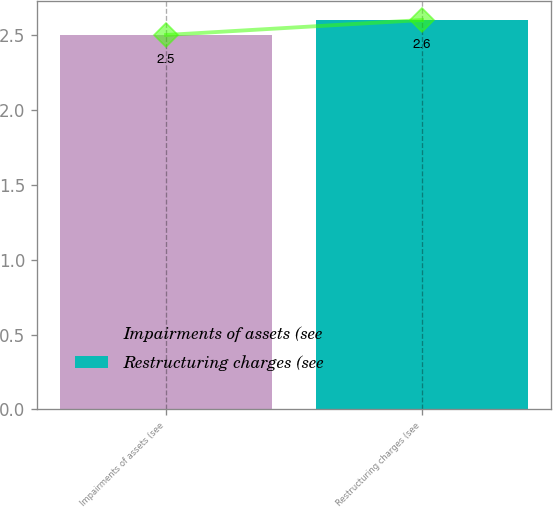Convert chart to OTSL. <chart><loc_0><loc_0><loc_500><loc_500><bar_chart><fcel>Impairments of assets (see<fcel>Restructuring charges (see<nl><fcel>2.5<fcel>2.6<nl></chart> 